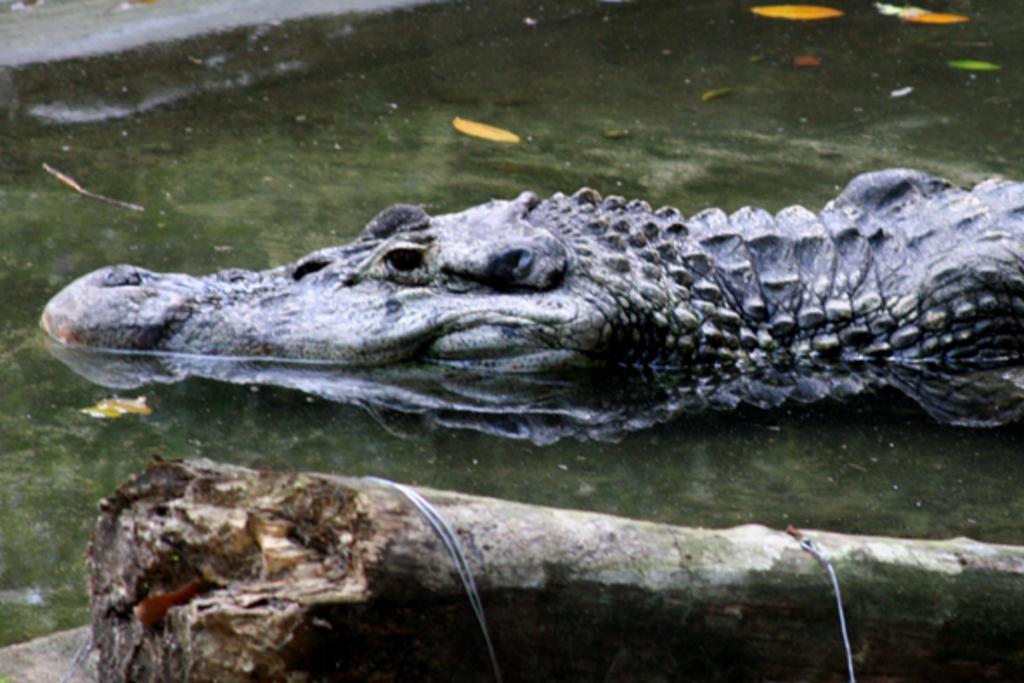Can you describe this image briefly? This picture shows a crocodile in the water and we see a tree bark on the side. 